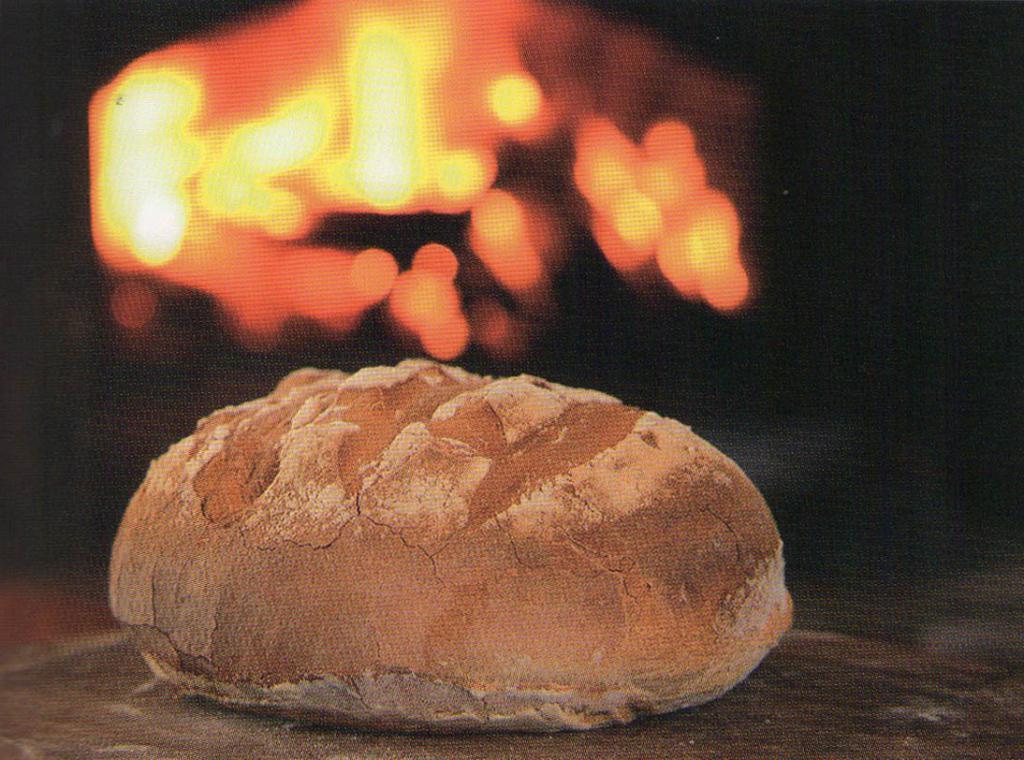Describe this image in one or two sentences. In this image we can see a food item on a surface. In the background of the image we can see the fire. 